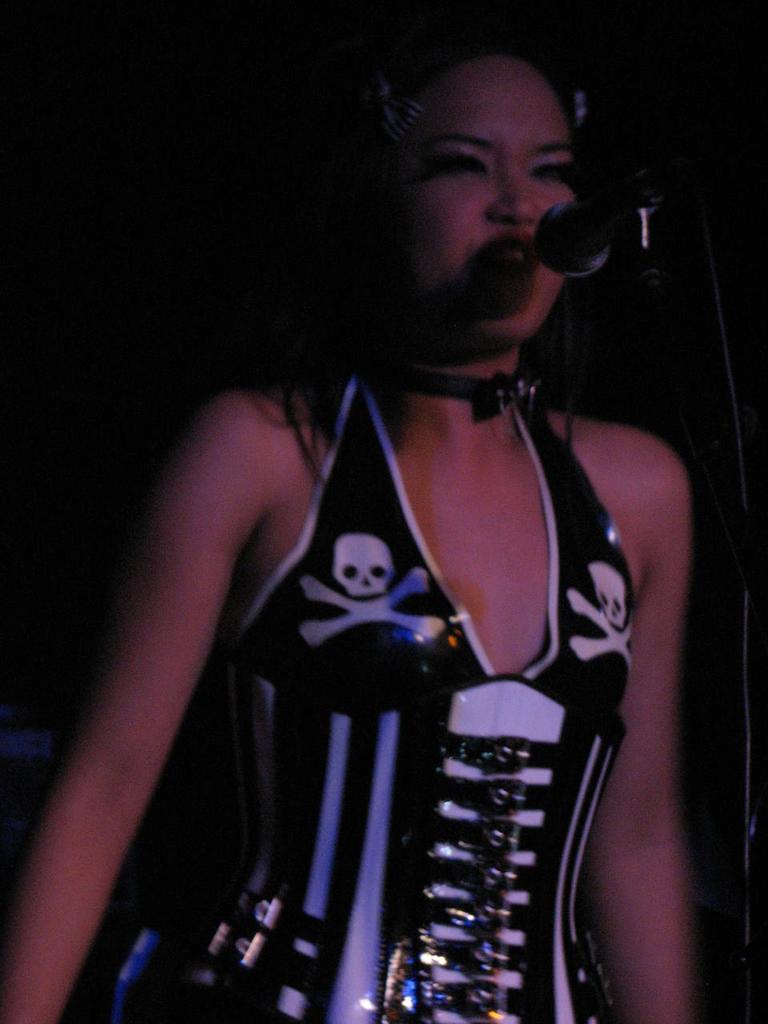In one or two sentences, can you explain what this image depicts? In this picture we can see a woman, in front of her we can see a mic and in the background we can see it is dark. 